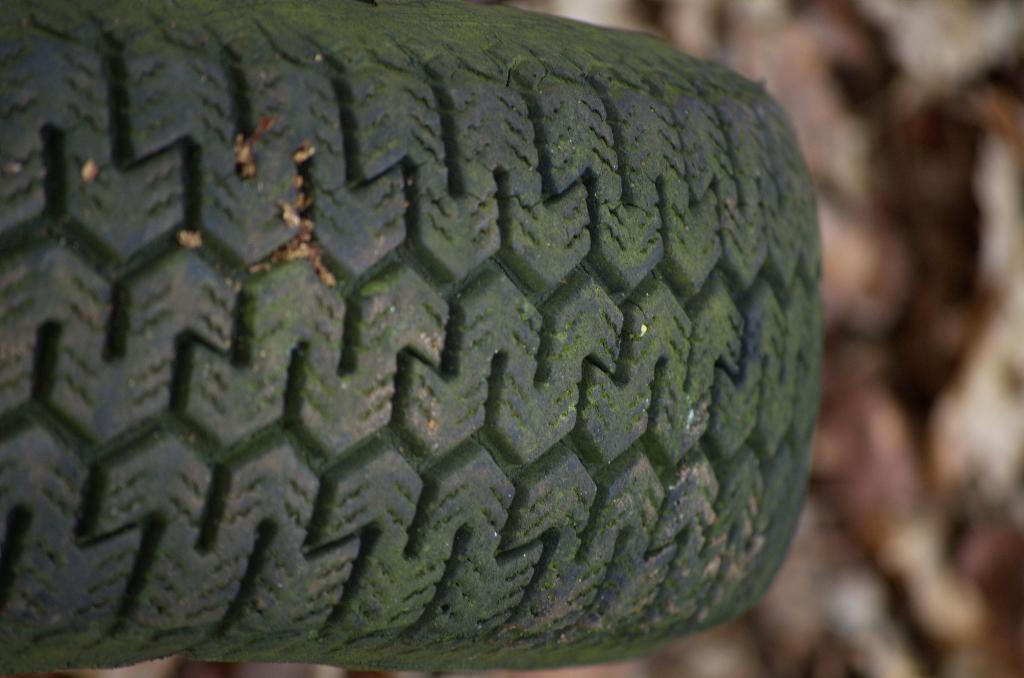What object can be seen in the image? There is a tire in the image. What type of calculator is on the desk in the image? There is no desk or calculator present in the image; it only features a tire. 